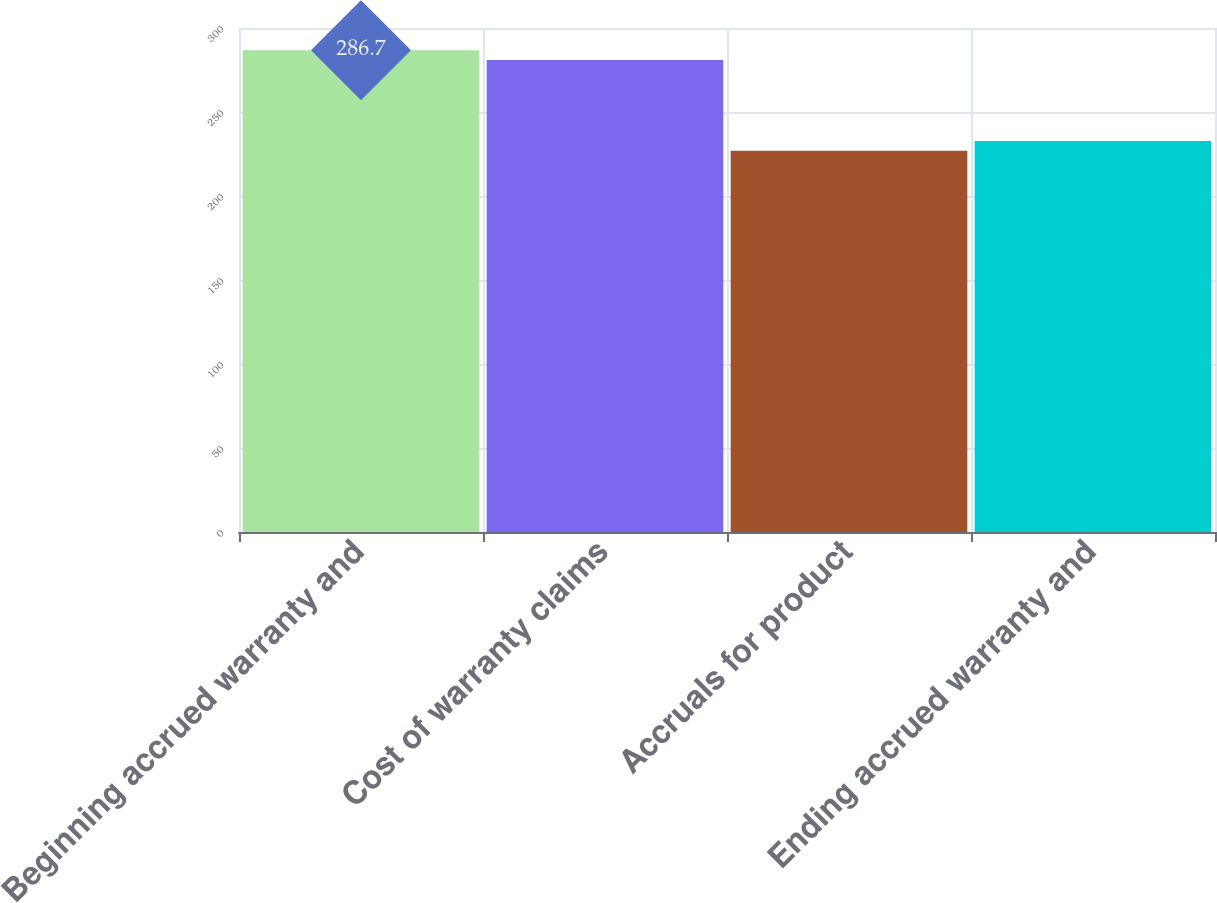Convert chart. <chart><loc_0><loc_0><loc_500><loc_500><bar_chart><fcel>Beginning accrued warranty and<fcel>Cost of warranty claims<fcel>Accruals for product<fcel>Ending accrued warranty and<nl><fcel>286.7<fcel>281<fcel>227<fcel>232.7<nl></chart> 